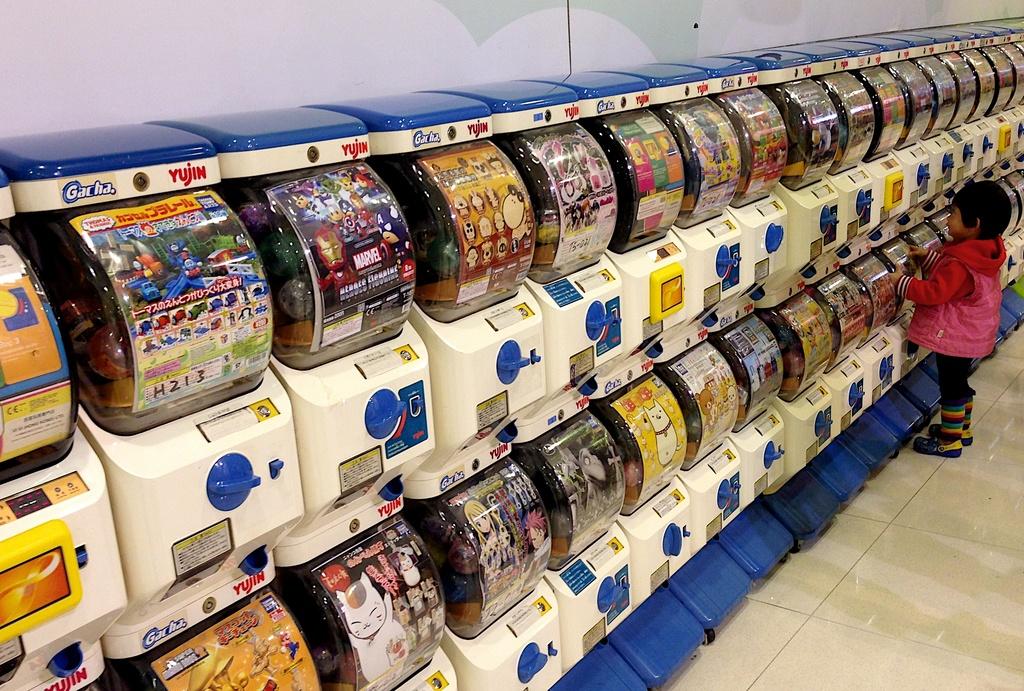Which company operates these machines?
Provide a succinct answer. Yujin. 